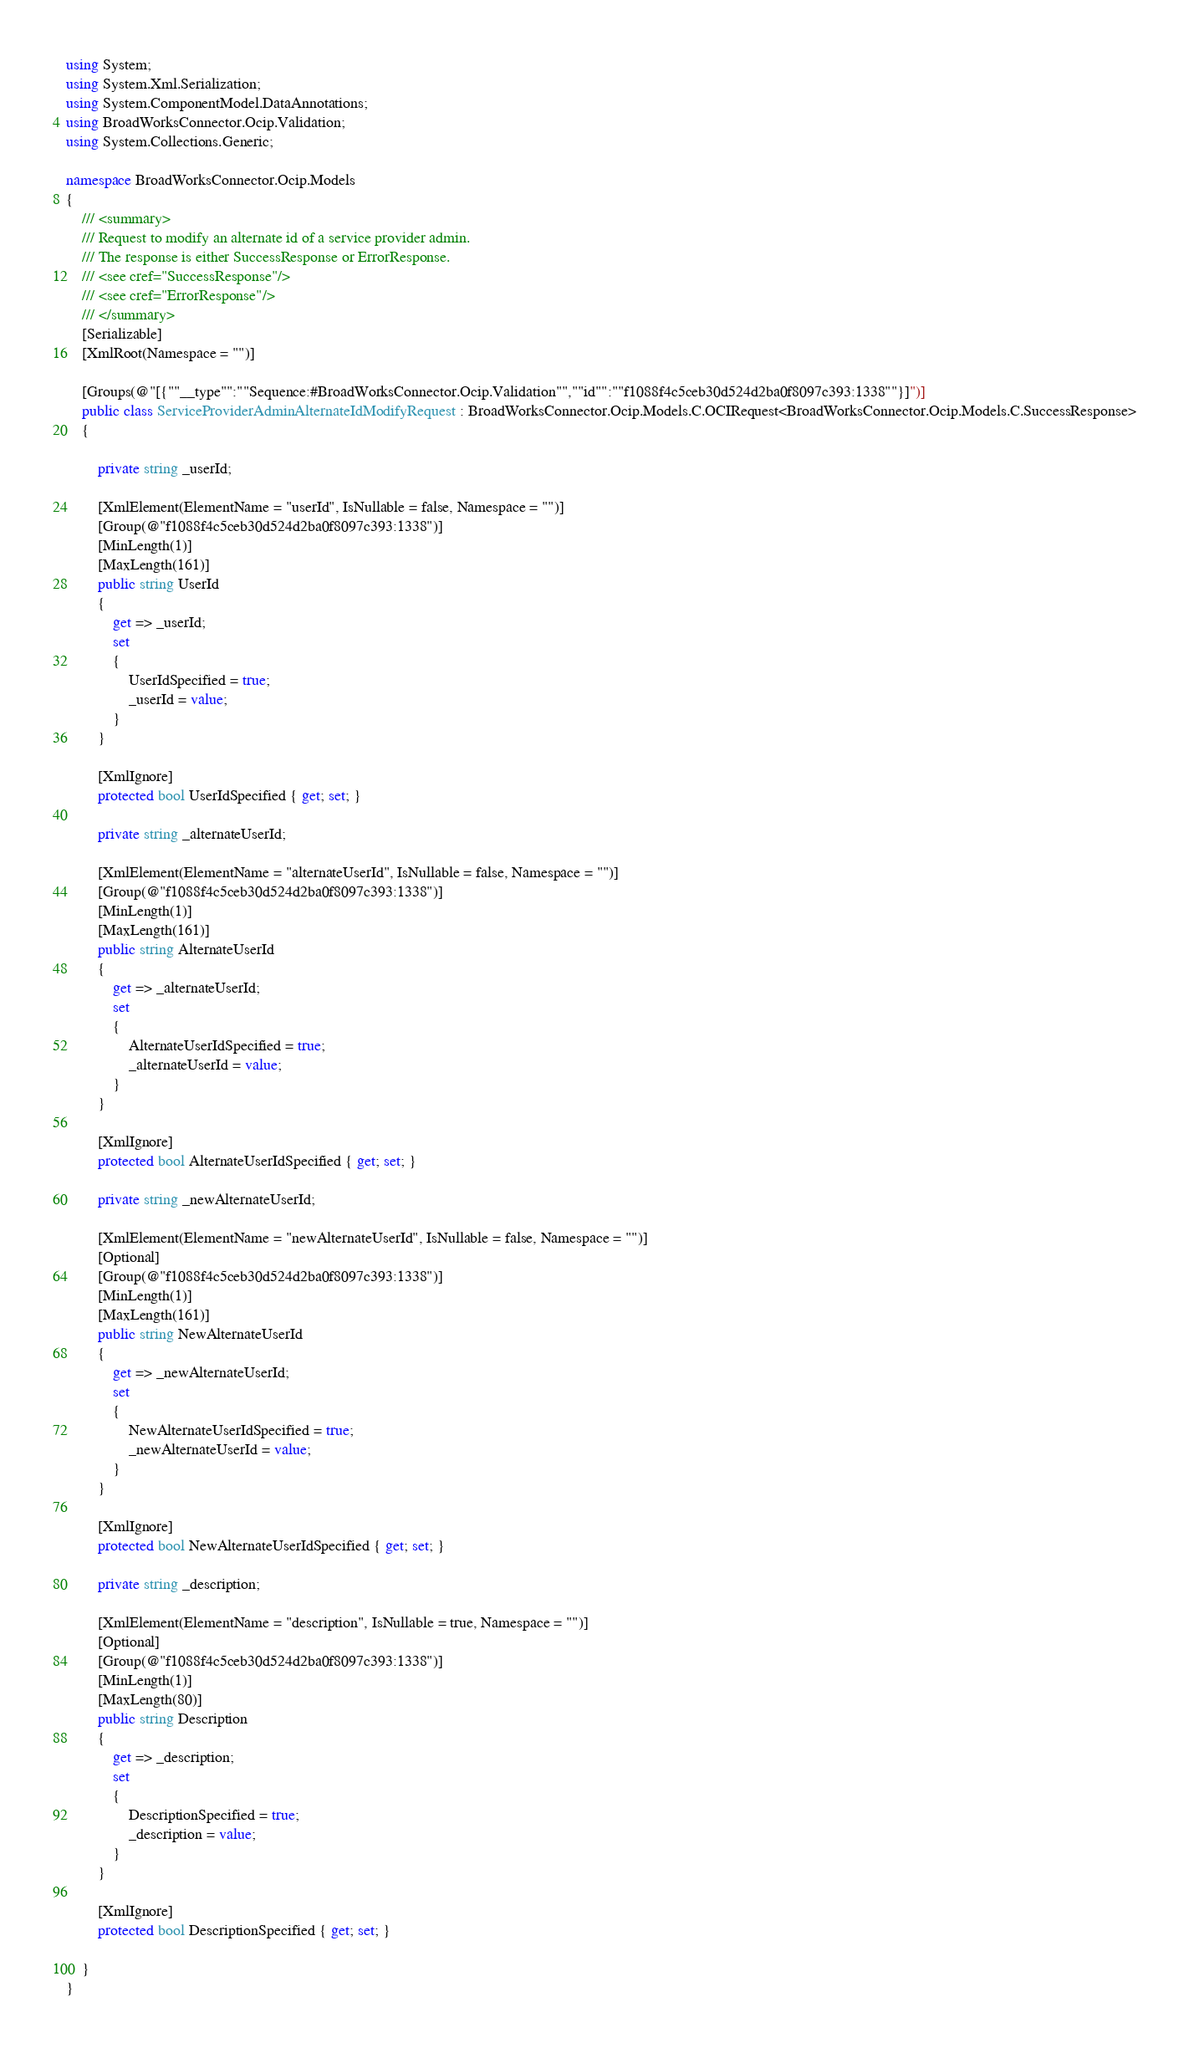Convert code to text. <code><loc_0><loc_0><loc_500><loc_500><_C#_>using System;
using System.Xml.Serialization;
using System.ComponentModel.DataAnnotations;
using BroadWorksConnector.Ocip.Validation;
using System.Collections.Generic;

namespace BroadWorksConnector.Ocip.Models
{
    /// <summary>
    /// Request to modify an alternate id of a service provider admin.
    /// The response is either SuccessResponse or ErrorResponse.
    /// <see cref="SuccessResponse"/>
    /// <see cref="ErrorResponse"/>
    /// </summary>
    [Serializable]
    [XmlRoot(Namespace = "")]

    [Groups(@"[{""__type"":""Sequence:#BroadWorksConnector.Ocip.Validation"",""id"":""f1088f4c5ceb30d524d2ba0f8097c393:1338""}]")]
    public class ServiceProviderAdminAlternateIdModifyRequest : BroadWorksConnector.Ocip.Models.C.OCIRequest<BroadWorksConnector.Ocip.Models.C.SuccessResponse>
    {

        private string _userId;

        [XmlElement(ElementName = "userId", IsNullable = false, Namespace = "")]
        [Group(@"f1088f4c5ceb30d524d2ba0f8097c393:1338")]
        [MinLength(1)]
        [MaxLength(161)]
        public string UserId
        {
            get => _userId;
            set
            {
                UserIdSpecified = true;
                _userId = value;
            }
        }

        [XmlIgnore]
        protected bool UserIdSpecified { get; set; }

        private string _alternateUserId;

        [XmlElement(ElementName = "alternateUserId", IsNullable = false, Namespace = "")]
        [Group(@"f1088f4c5ceb30d524d2ba0f8097c393:1338")]
        [MinLength(1)]
        [MaxLength(161)]
        public string AlternateUserId
        {
            get => _alternateUserId;
            set
            {
                AlternateUserIdSpecified = true;
                _alternateUserId = value;
            }
        }

        [XmlIgnore]
        protected bool AlternateUserIdSpecified { get; set; }

        private string _newAlternateUserId;

        [XmlElement(ElementName = "newAlternateUserId", IsNullable = false, Namespace = "")]
        [Optional]
        [Group(@"f1088f4c5ceb30d524d2ba0f8097c393:1338")]
        [MinLength(1)]
        [MaxLength(161)]
        public string NewAlternateUserId
        {
            get => _newAlternateUserId;
            set
            {
                NewAlternateUserIdSpecified = true;
                _newAlternateUserId = value;
            }
        }

        [XmlIgnore]
        protected bool NewAlternateUserIdSpecified { get; set; }

        private string _description;

        [XmlElement(ElementName = "description", IsNullable = true, Namespace = "")]
        [Optional]
        [Group(@"f1088f4c5ceb30d524d2ba0f8097c393:1338")]
        [MinLength(1)]
        [MaxLength(80)]
        public string Description
        {
            get => _description;
            set
            {
                DescriptionSpecified = true;
                _description = value;
            }
        }

        [XmlIgnore]
        protected bool DescriptionSpecified { get; set; }

    }
}
</code> 